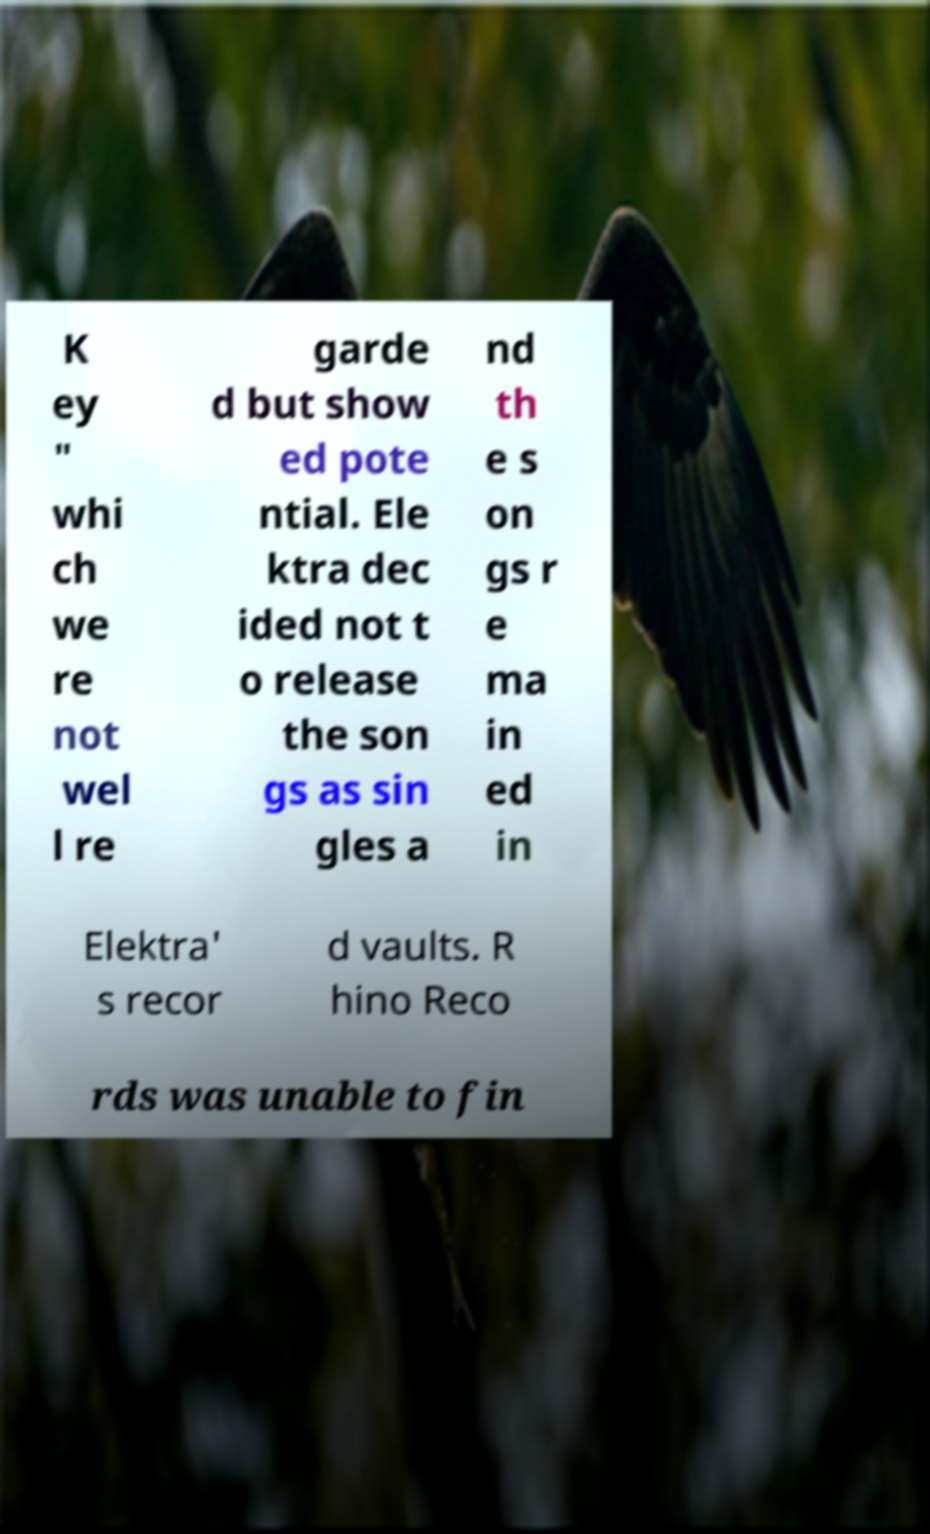I need the written content from this picture converted into text. Can you do that? K ey " whi ch we re not wel l re garde d but show ed pote ntial. Ele ktra dec ided not t o release the son gs as sin gles a nd th e s on gs r e ma in ed in Elektra' s recor d vaults. R hino Reco rds was unable to fin 